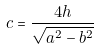<formula> <loc_0><loc_0><loc_500><loc_500>c = \frac { 4 h } { \sqrt { a ^ { 2 } - b ^ { 2 } } }</formula> 